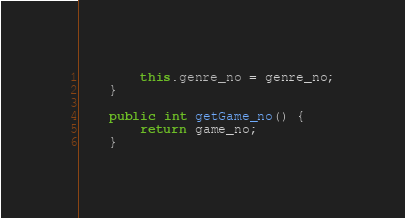Convert code to text. <code><loc_0><loc_0><loc_500><loc_500><_Java_>		this.genre_no = genre_no;
	}

	public int getGame_no() {
		return game_no;
	}
</code> 